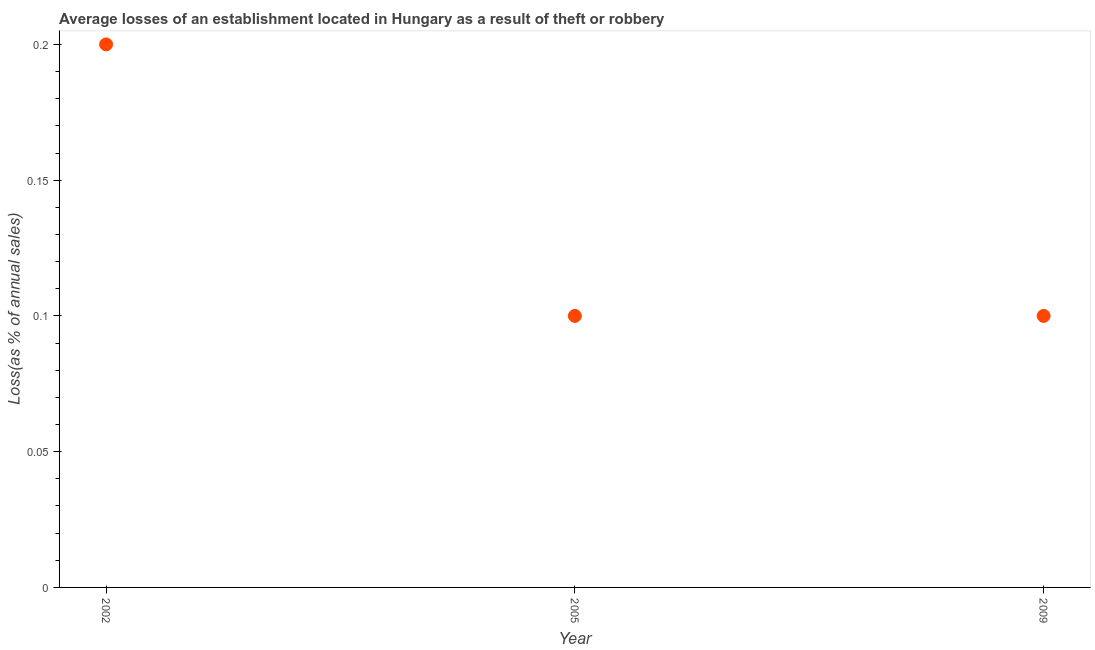Across all years, what is the minimum losses due to theft?
Offer a terse response. 0.1. In which year was the losses due to theft maximum?
Offer a terse response. 2002. What is the difference between the losses due to theft in 2002 and 2005?
Your response must be concise. 0.1. What is the average losses due to theft per year?
Offer a terse response. 0.13. In how many years, is the losses due to theft greater than 0.19000000000000003 %?
Ensure brevity in your answer.  1. What is the ratio of the losses due to theft in 2005 to that in 2009?
Your answer should be very brief. 1. Is the losses due to theft in 2002 less than that in 2005?
Your answer should be very brief. No. Is the difference between the losses due to theft in 2002 and 2009 greater than the difference between any two years?
Give a very brief answer. Yes. What is the difference between the highest and the second highest losses due to theft?
Ensure brevity in your answer.  0.1. Is the sum of the losses due to theft in 2005 and 2009 greater than the maximum losses due to theft across all years?
Give a very brief answer. No. What is the difference between the highest and the lowest losses due to theft?
Offer a terse response. 0.1. In how many years, is the losses due to theft greater than the average losses due to theft taken over all years?
Offer a terse response. 1. How many dotlines are there?
Give a very brief answer. 1. What is the difference between two consecutive major ticks on the Y-axis?
Your answer should be compact. 0.05. Are the values on the major ticks of Y-axis written in scientific E-notation?
Provide a short and direct response. No. What is the title of the graph?
Keep it short and to the point. Average losses of an establishment located in Hungary as a result of theft or robbery. What is the label or title of the Y-axis?
Provide a short and direct response. Loss(as % of annual sales). What is the difference between the Loss(as % of annual sales) in 2005 and 2009?
Offer a terse response. 0. What is the ratio of the Loss(as % of annual sales) in 2002 to that in 2005?
Provide a short and direct response. 2. What is the ratio of the Loss(as % of annual sales) in 2002 to that in 2009?
Your response must be concise. 2. What is the ratio of the Loss(as % of annual sales) in 2005 to that in 2009?
Provide a short and direct response. 1. 